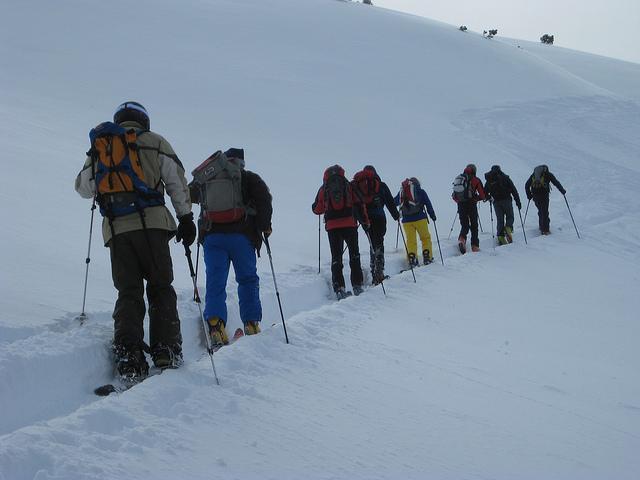How many backpacks are in the photo?
Give a very brief answer. 2. How many people are in the photo?
Give a very brief answer. 5. How many pieces of sandwich are there?
Give a very brief answer. 0. 